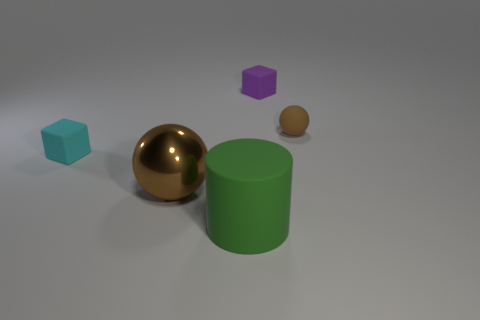Is there anything else that is the same shape as the large green matte object? Upon reviewing the image, it appears that there are no other objects with the same cylindrical shape as the large green matte object. Each item in the scene has a unique shape, including a gold sphere, a brown sphere smaller than the gold one, and two cubes—one purple and one teal—with different sizes. 